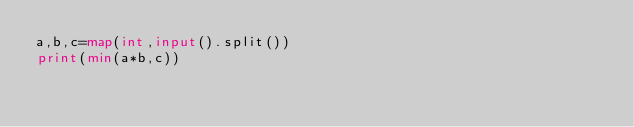Convert code to text. <code><loc_0><loc_0><loc_500><loc_500><_Python_>a,b,c=map(int,input().split())
print(min(a*b,c))</code> 